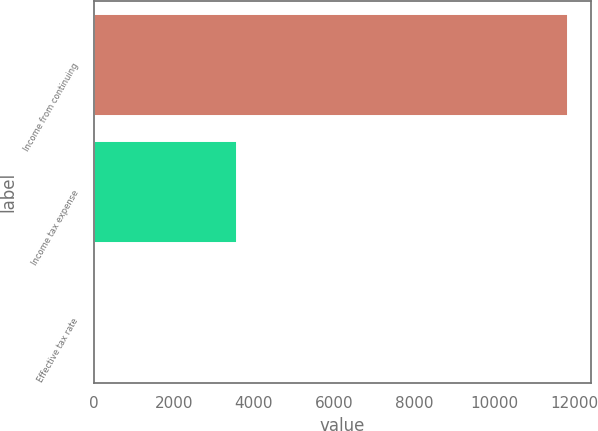Convert chart to OTSL. <chart><loc_0><loc_0><loc_500><loc_500><bar_chart><fcel>Income from continuing<fcel>Income tax expense<fcel>Effective tax rate<nl><fcel>11839<fcel>3585<fcel>30.3<nl></chart> 